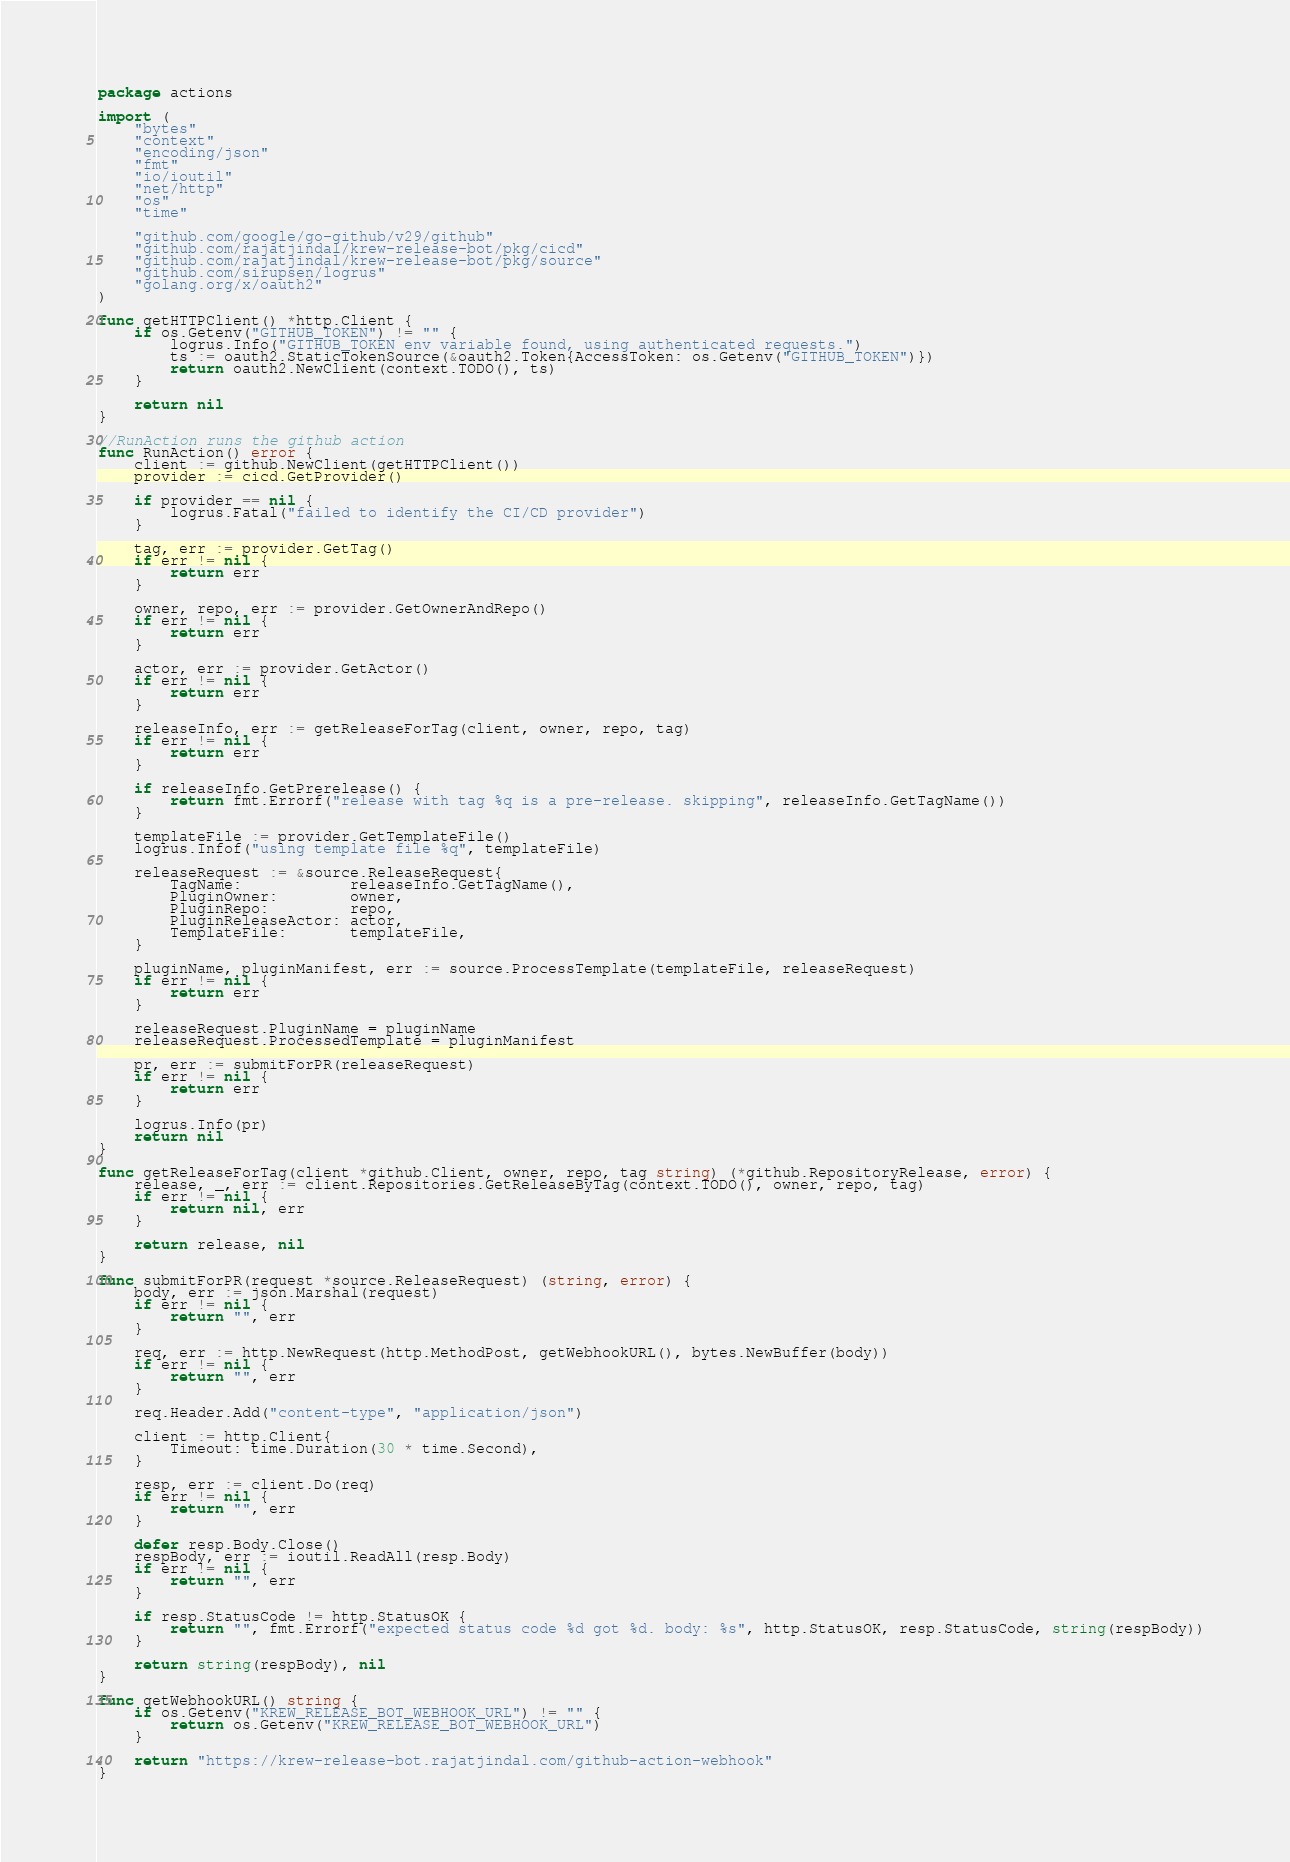<code> <loc_0><loc_0><loc_500><loc_500><_Go_>package actions

import (
	"bytes"
	"context"
	"encoding/json"
	"fmt"
	"io/ioutil"
	"net/http"
	"os"
	"time"

	"github.com/google/go-github/v29/github"
	"github.com/rajatjindal/krew-release-bot/pkg/cicd"
	"github.com/rajatjindal/krew-release-bot/pkg/source"
	"github.com/sirupsen/logrus"
	"golang.org/x/oauth2"
)

func getHTTPClient() *http.Client {
	if os.Getenv("GITHUB_TOKEN") != "" {
		logrus.Info("GITHUB_TOKEN env variable found, using authenticated requests.")
		ts := oauth2.StaticTokenSource(&oauth2.Token{AccessToken: os.Getenv("GITHUB_TOKEN")})
		return oauth2.NewClient(context.TODO(), ts)
	}

	return nil
}

//RunAction runs the github action
func RunAction() error {
	client := github.NewClient(getHTTPClient())
	provider := cicd.GetProvider()

	if provider == nil {
		logrus.Fatal("failed to identify the CI/CD provider")
	}

	tag, err := provider.GetTag()
	if err != nil {
		return err
	}

	owner, repo, err := provider.GetOwnerAndRepo()
	if err != nil {
		return err
	}

	actor, err := provider.GetActor()
	if err != nil {
		return err
	}

	releaseInfo, err := getReleaseForTag(client, owner, repo, tag)
	if err != nil {
		return err
	}

	if releaseInfo.GetPrerelease() {
		return fmt.Errorf("release with tag %q is a pre-release. skipping", releaseInfo.GetTagName())
	}

	templateFile := provider.GetTemplateFile()
	logrus.Infof("using template file %q", templateFile)

	releaseRequest := &source.ReleaseRequest{
		TagName:            releaseInfo.GetTagName(),
		PluginOwner:        owner,
		PluginRepo:         repo,
		PluginReleaseActor: actor,
		TemplateFile:       templateFile,
	}

	pluginName, pluginManifest, err := source.ProcessTemplate(templateFile, releaseRequest)
	if err != nil {
		return err
	}

	releaseRequest.PluginName = pluginName
	releaseRequest.ProcessedTemplate = pluginManifest

	pr, err := submitForPR(releaseRequest)
	if err != nil {
		return err
	}

	logrus.Info(pr)
	return nil
}

func getReleaseForTag(client *github.Client, owner, repo, tag string) (*github.RepositoryRelease, error) {
	release, _, err := client.Repositories.GetReleaseByTag(context.TODO(), owner, repo, tag)
	if err != nil {
		return nil, err
	}

	return release, nil
}

func submitForPR(request *source.ReleaseRequest) (string, error) {
	body, err := json.Marshal(request)
	if err != nil {
		return "", err
	}

	req, err := http.NewRequest(http.MethodPost, getWebhookURL(), bytes.NewBuffer(body))
	if err != nil {
		return "", err
	}

	req.Header.Add("content-type", "application/json")

	client := http.Client{
		Timeout: time.Duration(30 * time.Second),
	}

	resp, err := client.Do(req)
	if err != nil {
		return "", err
	}

	defer resp.Body.Close()
	respBody, err := ioutil.ReadAll(resp.Body)
	if err != nil {
		return "", err
	}

	if resp.StatusCode != http.StatusOK {
		return "", fmt.Errorf("expected status code %d got %d. body: %s", http.StatusOK, resp.StatusCode, string(respBody))
	}

	return string(respBody), nil
}

func getWebhookURL() string {
	if os.Getenv("KREW_RELEASE_BOT_WEBHOOK_URL") != "" {
		return os.Getenv("KREW_RELEASE_BOT_WEBHOOK_URL")
	}

	return "https://krew-release-bot.rajatjindal.com/github-action-webhook"
}
</code> 